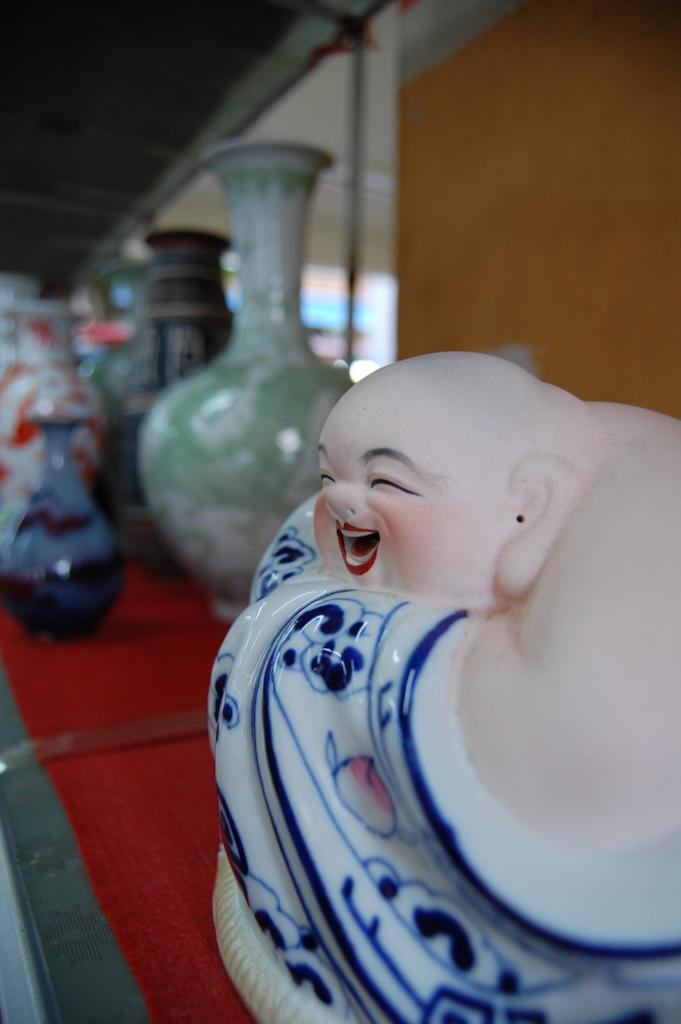What is the main subject of the image? There is a statue of a Laughing Buddha in the image. What other objects can be seen in the image? There are colorful vases in the image. What color is the surface on which the objects are placed? The objects are placed on a red surface. How would you describe the background of the image? The background of the image is blurry. What type of skin condition can be seen on the statue in the image? There is no skin condition visible on the statue in the image, as it is a statue made of a material that does not have skin. 